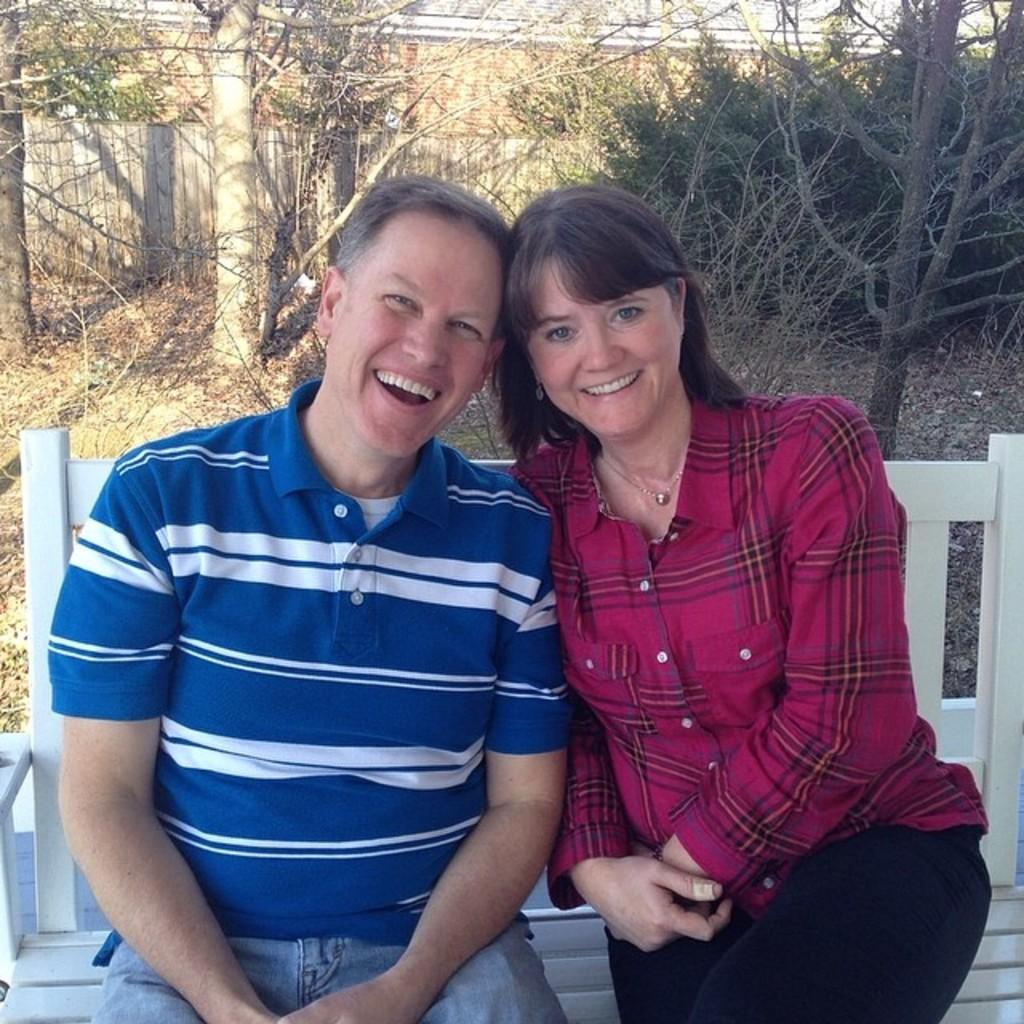Who is present in the image? There is a man and a woman in the image. What are they doing in the image? They are sitting on a bench. Can you describe the bench? The bench is white in color. How are the man and woman feeling in the image? They are smiling. What can be seen in the background of the image? There is grass, plants, and poles in the background of the image. What is the title of the book the man is reading in the image? There is no book present in the image, so it is not possible to determine the title. --- 